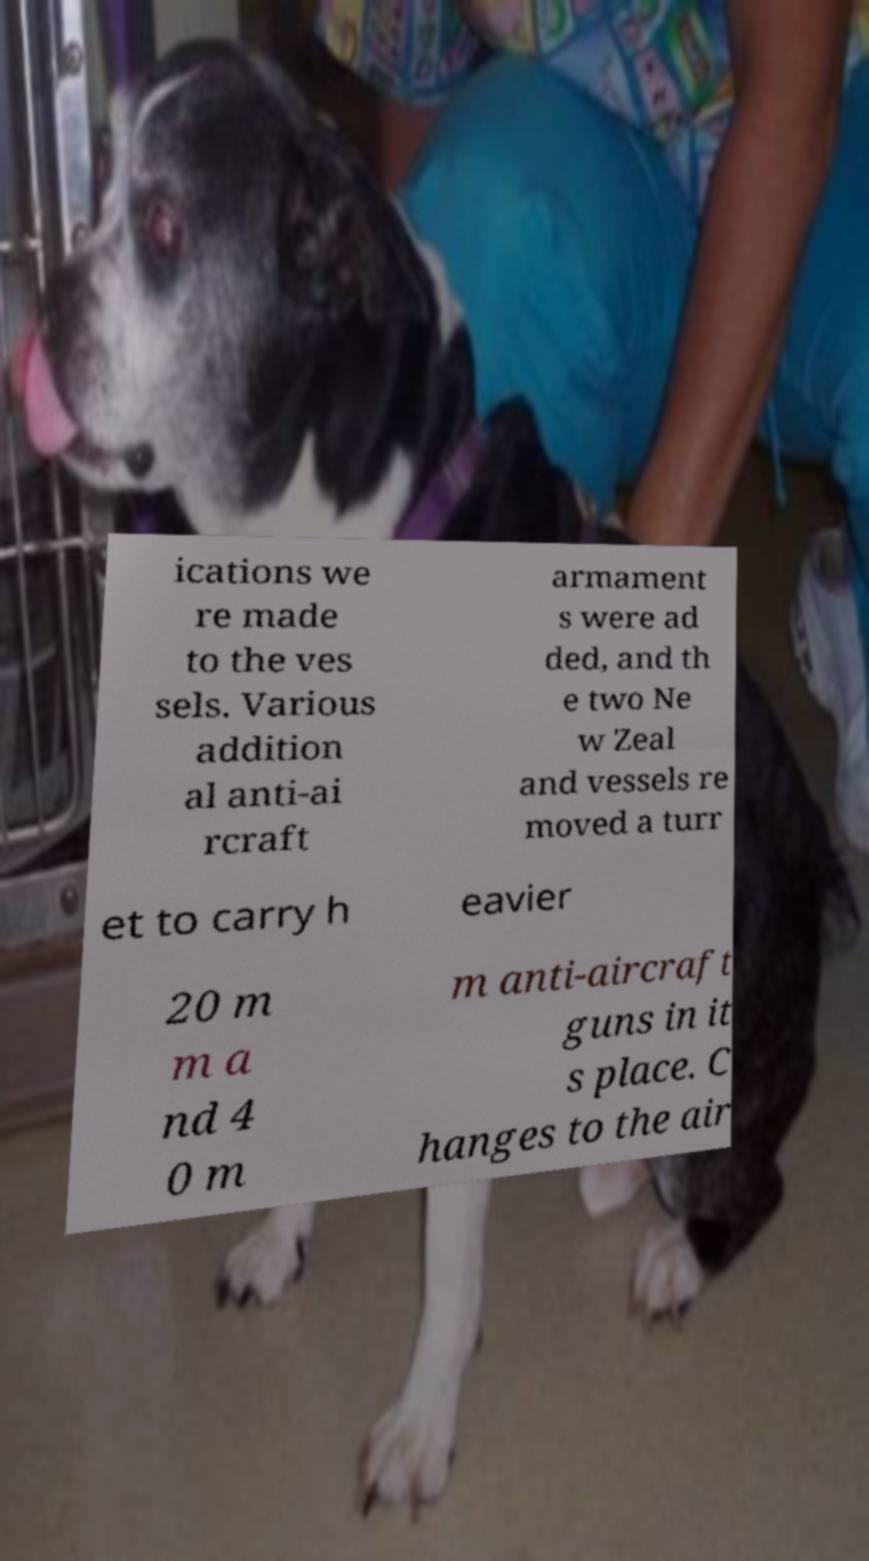There's text embedded in this image that I need extracted. Can you transcribe it verbatim? ications we re made to the ves sels. Various addition al anti-ai rcraft armament s were ad ded, and th e two Ne w Zeal and vessels re moved a turr et to carry h eavier 20 m m a nd 4 0 m m anti-aircraft guns in it s place. C hanges to the air 